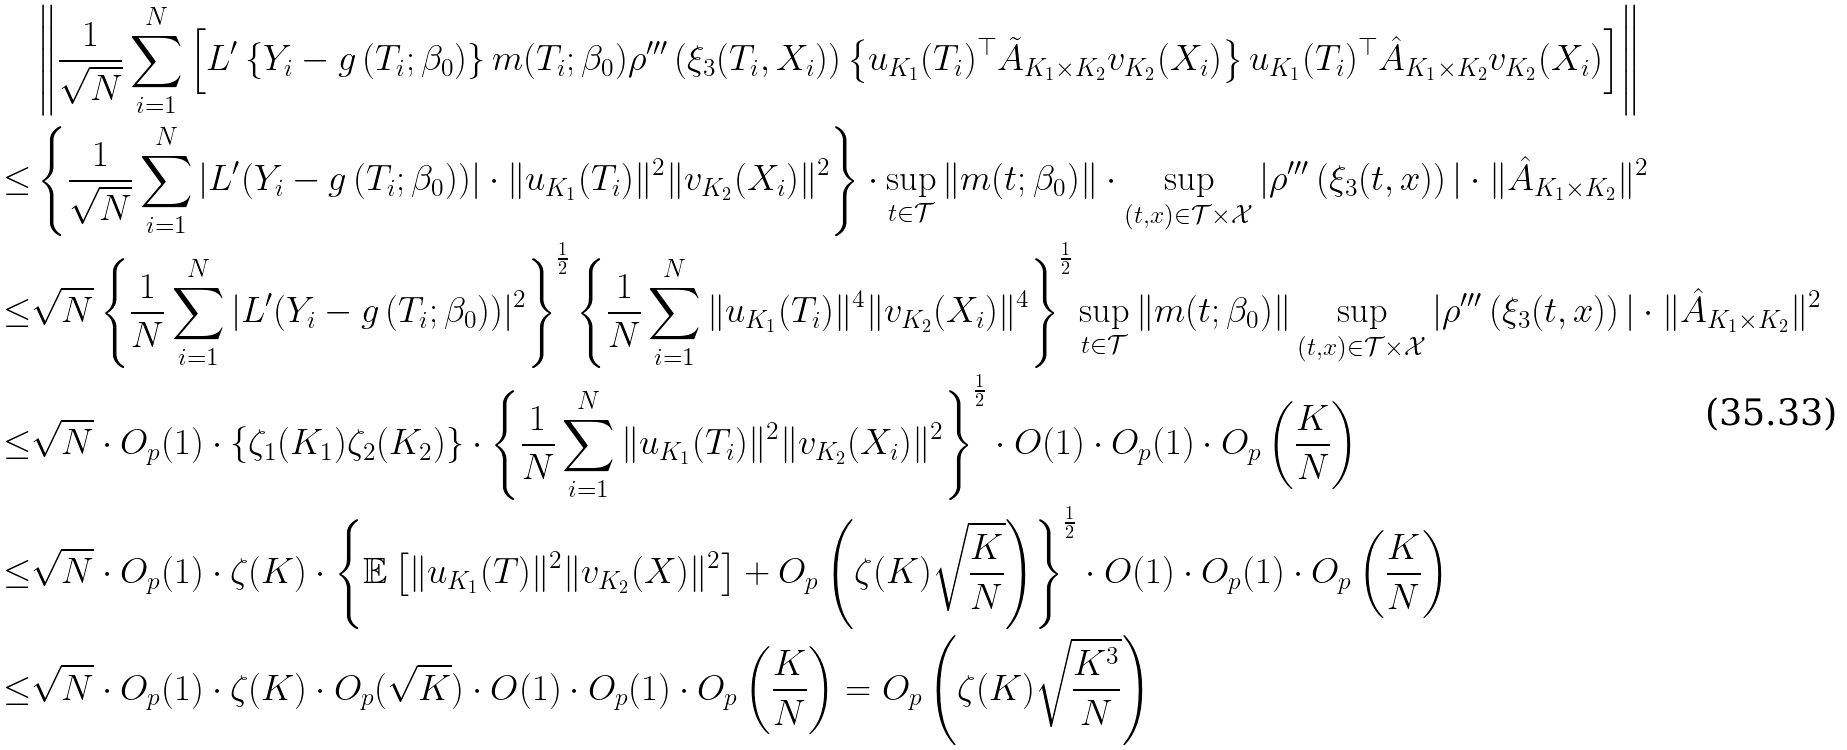Convert formula to latex. <formula><loc_0><loc_0><loc_500><loc_500>& \left \| \frac { 1 } { \sqrt { N } } \sum _ { i = 1 } ^ { N } \left [ L ^ { \prime } \left \{ Y _ { i } - g \left ( T _ { i } ; \beta _ { 0 } \right ) \right \} m ( T _ { i } ; \beta _ { 0 } ) \rho ^ { \prime \prime \prime } \left ( \xi _ { 3 } ( T _ { i } , X _ { i } ) \right ) \left \{ u _ { K _ { 1 } } ( T _ { i } ) ^ { \top } \tilde { A } _ { K _ { 1 } \times K _ { 2 } } v _ { K _ { 2 } } ( X _ { i } ) \right \} u _ { K _ { 1 } } ( T _ { i } ) ^ { \top } \hat { A } _ { K _ { 1 } \times K _ { 2 } } v _ { K _ { 2 } } ( X _ { i } ) \right ] \right \| \\ \leq & \left \{ \frac { 1 } { \sqrt { N } } \sum _ { i = 1 } ^ { N } | L ^ { \prime } ( Y _ { i } - g \left ( T _ { i } ; \beta _ { 0 } \right ) ) | \cdot \| u _ { K _ { 1 } } ( T _ { i } ) \| ^ { 2 } \| v _ { K _ { 2 } } ( X _ { i } ) \| ^ { 2 } \right \} \cdot \sup _ { t \in \mathcal { T } } \| m ( t ; \beta _ { 0 } ) \| \cdot \sup _ { ( t , x ) \in \mathcal { T } \times \mathcal { X } } | \rho ^ { \prime \prime \prime } \left ( \xi _ { 3 } ( t , x ) \right ) | \cdot \| \hat { A } _ { K _ { 1 } \times K _ { 2 } } \| ^ { 2 } \\ \leq & \sqrt { N } \left \{ \frac { 1 } { N } \sum _ { i = 1 } ^ { N } | L ^ { \prime } ( Y _ { i } - g \left ( T _ { i } ; \beta _ { 0 } \right ) ) | ^ { 2 } \right \} ^ { \frac { 1 } { 2 } } \left \{ \frac { 1 } { N } \sum _ { i = 1 } ^ { N } \| u _ { K _ { 1 } } ( T _ { i } ) \| ^ { 4 } \| v _ { K _ { 2 } } ( X _ { i } ) \| ^ { 4 } \right \} ^ { \frac { 1 } { 2 } } \sup _ { t \in \mathcal { T } } \| m ( t ; \beta _ { 0 } ) \| \sup _ { ( t , x ) \in \mathcal { T } \times \mathcal { X } } | \rho ^ { \prime \prime \prime } \left ( \xi _ { 3 } ( t , x ) \right ) | \cdot \| \hat { A } _ { K _ { 1 } \times K _ { 2 } } \| ^ { 2 } \\ \leq & \sqrt { N } \cdot O _ { p } ( 1 ) \cdot \{ \zeta _ { 1 } ( K _ { 1 } ) \zeta _ { 2 } ( K _ { 2 } ) \} \cdot \left \{ \frac { 1 } { N } \sum _ { i = 1 } ^ { N } \| u _ { K _ { 1 } } ( T _ { i } ) \| ^ { 2 } \| v _ { K _ { 2 } } ( X _ { i } ) \| ^ { 2 } \right \} ^ { \frac { 1 } { 2 } } \cdot O ( 1 ) \cdot O _ { p } ( 1 ) \cdot O _ { p } \left ( \frac { K } { N } \right ) \\ \leq & \sqrt { N } \cdot O _ { p } ( 1 ) \cdot \zeta ( K ) \cdot \left \{ \mathbb { E } \left [ \| u _ { K _ { 1 } } ( T ) \| ^ { 2 } \| v _ { K _ { 2 } } ( X ) \| ^ { 2 } \right ] + O _ { p } \left ( \zeta ( K ) \sqrt { \frac { K } { N } } \right ) \right \} ^ { \frac { 1 } { 2 } } \cdot O ( 1 ) \cdot O _ { p } ( 1 ) \cdot O _ { p } \left ( \frac { K } { N } \right ) \\ \leq & \sqrt { N } \cdot O _ { p } ( 1 ) \cdot \zeta ( K ) \cdot O _ { p } ( \sqrt { K } ) \cdot O ( 1 ) \cdot O _ { p } ( 1 ) \cdot O _ { p } \left ( \frac { K } { N } \right ) = O _ { p } \left ( \zeta ( K ) \sqrt { \frac { K ^ { 3 } } { N } } \right )</formula> 